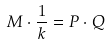Convert formula to latex. <formula><loc_0><loc_0><loc_500><loc_500>M \cdot \frac { 1 } { k } = P \cdot Q</formula> 